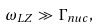Convert formula to latex. <formula><loc_0><loc_0><loc_500><loc_500>\omega _ { L Z } \gg \Gamma _ { n u c } ,</formula> 